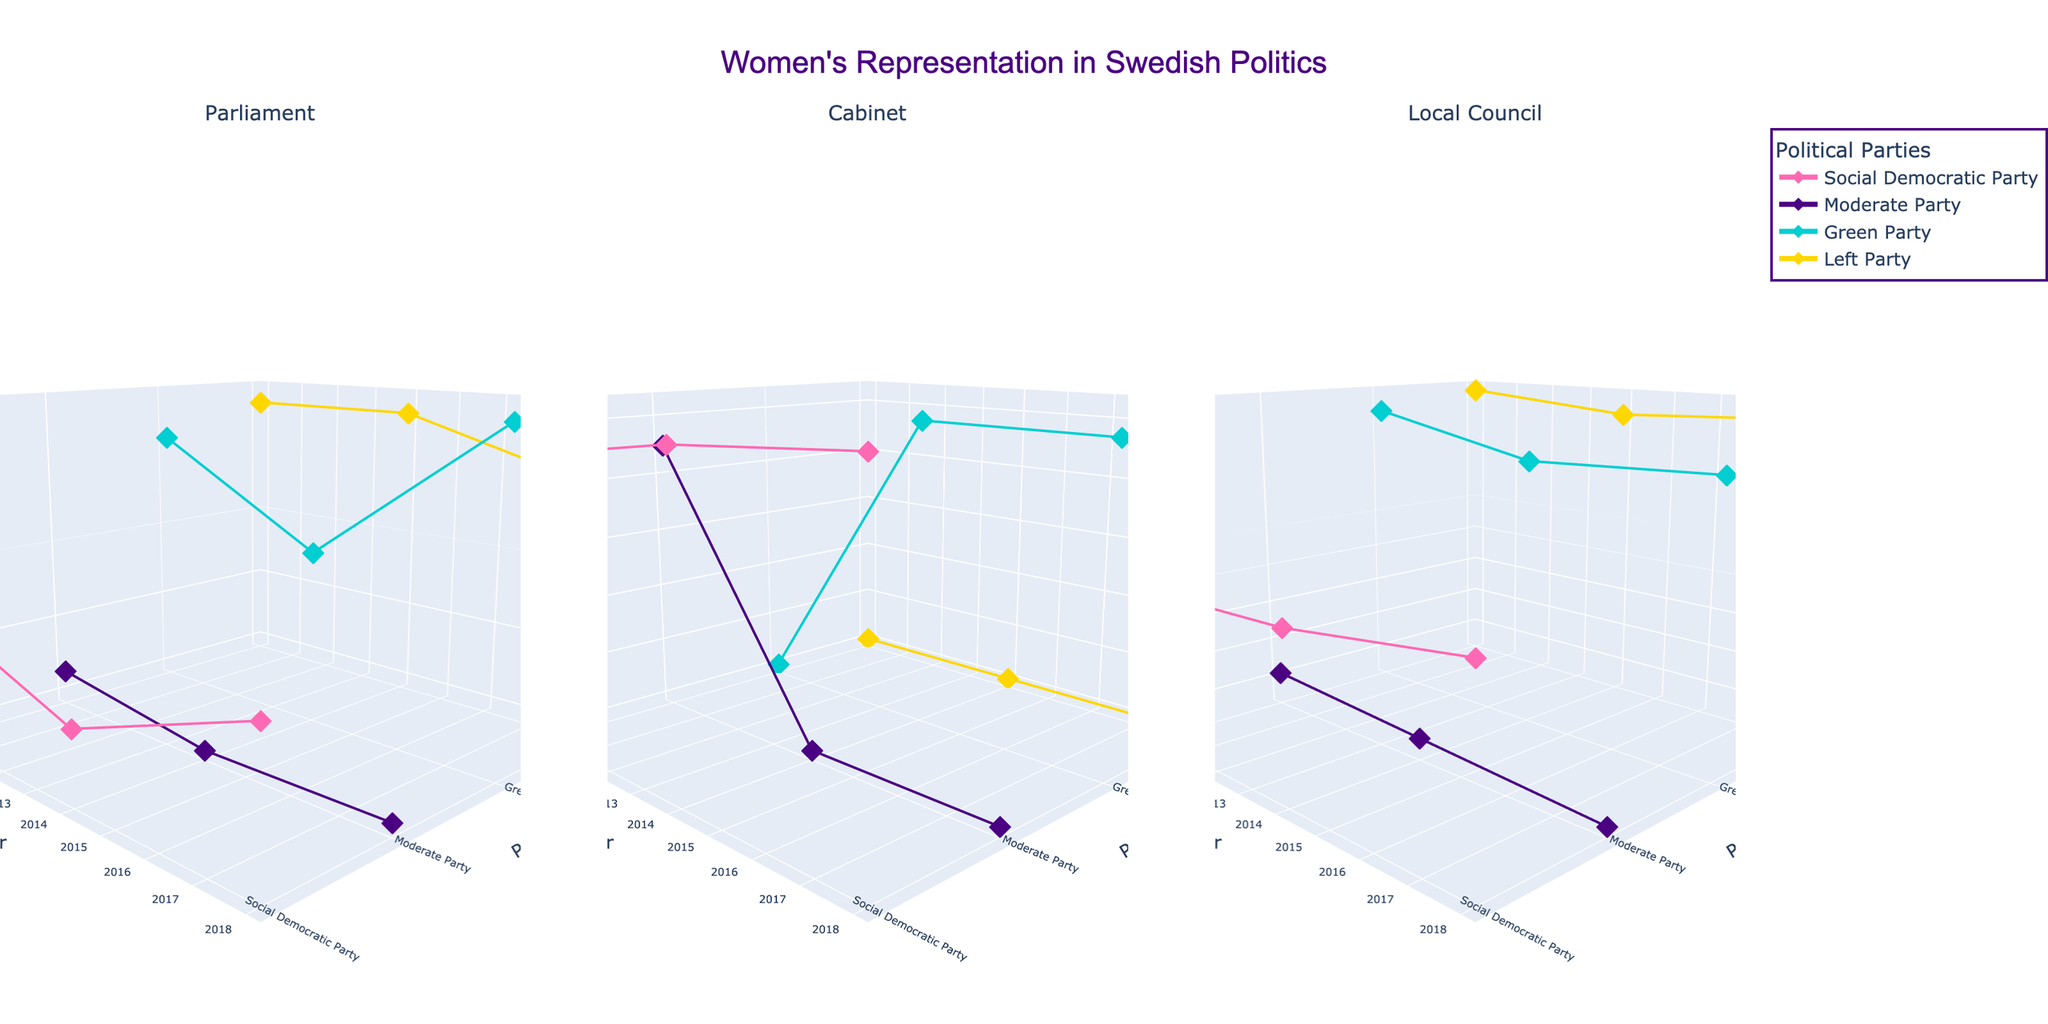What's the title of the figure? The title of the figure is displayed at the top center of the plot.
Answer: Women's Representation in Swedish Politics How many political parties are represented in the figure? The figure includes multiple 3D scatter plots, each representing data for specific parties indicated by different colors in the legend. Count the unique entries in the legend.
Answer: Four What is the color used to represent the Green Party? The Green Party is represented in the legend with a specific color, which you can identify.
Answer: #00CED1 In which year did the Left Party have the highest percentage of women in the Parliament? Look at the trace line for the Left Party in the Parliament subplot and identify the year with the highest z-axis value (Percentage).
Answer: 2010 What's the range of women's representation percentage for the Social Democratic Party in the local councils from 2010 to 2018? Check the minimum and maximum z-axis values (Percentage) of the points representing the Social Democratic Party in the Local Council subplot.
Answer: 43.0 to 43.8 Which party had a zero percentage of women in the Cabinet in 2018? Locate the subplot for the Cabinet and identify the party with a data point at 0% on the z-axis in 2018.
Answer: Moderate Party and Left Party On average, how did the Social Democratic Party's women's representation in the Cabinet change from 2010 to 2018? Calculate the average of percentages for the Social Democratic Party in the Cabinet for the years 2010, 2014, and 2018.
Answer: (45.5 + 50.0 + 52.2) / 3 = 49.23% In which position did the Green Party have the highest overall women's representation? Compare the z-axis values (Percentages) of the Green Party across all three subplots and identify the position with the highest values.
Answer: Parliament Between 2010 and 2018, which party showed the greatest fluctuation in women's representation in the Parliament? Look at the range of z-axis values (Percentages) for each party in the Parliament subplot and identify the party with the largest difference.
Answer: Social Democratic Party How did women's representation in the Local Council for the Moderate Party change from 2010 to 2018? Observe the trace for the Moderate Party in the Local Council subplot from 2010, 2014 to 2018 and describe the trend.
Answer: Decreased from 40.1 in 2010 to 39.5 in 2018 